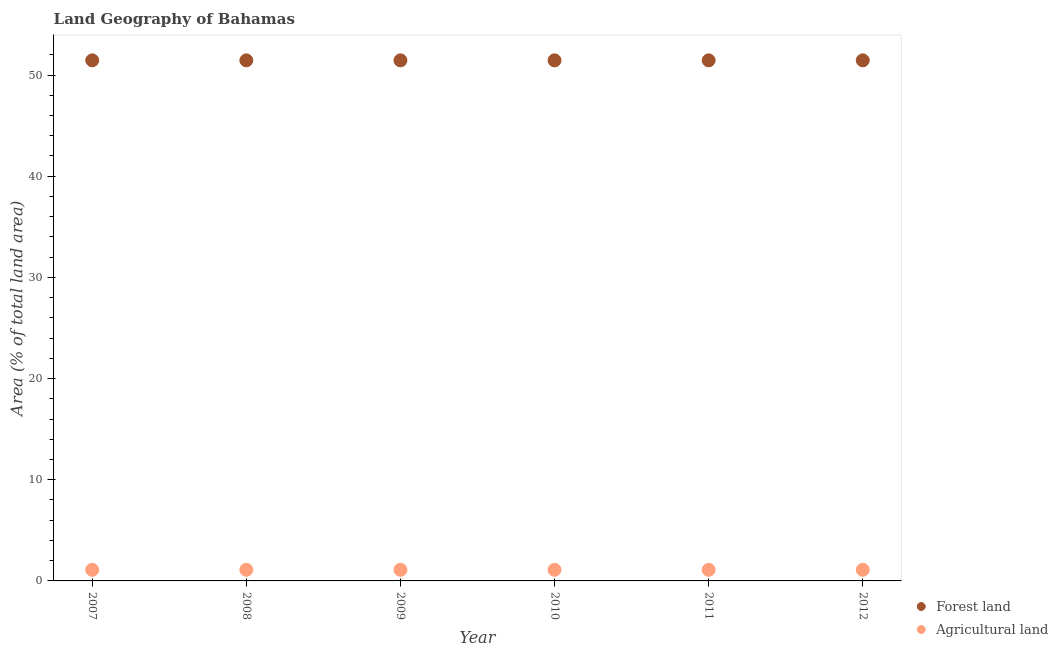What is the percentage of land area under agriculture in 2011?
Give a very brief answer. 1.1. Across all years, what is the maximum percentage of land area under agriculture?
Keep it short and to the point. 1.1. Across all years, what is the minimum percentage of land area under agriculture?
Ensure brevity in your answer.  1.1. In which year was the percentage of land area under agriculture maximum?
Offer a terse response. 2007. What is the total percentage of land area under agriculture in the graph?
Offer a terse response. 6.59. What is the difference between the percentage of land area under forests in 2007 and that in 2011?
Make the answer very short. 0. What is the difference between the percentage of land area under agriculture in 2007 and the percentage of land area under forests in 2012?
Provide a succinct answer. -50.35. What is the average percentage of land area under agriculture per year?
Offer a very short reply. 1.1. In the year 2008, what is the difference between the percentage of land area under agriculture and percentage of land area under forests?
Provide a short and direct response. -50.35. In how many years, is the percentage of land area under agriculture greater than 8 %?
Your response must be concise. 0. Is the difference between the percentage of land area under agriculture in 2009 and 2010 greater than the difference between the percentage of land area under forests in 2009 and 2010?
Give a very brief answer. No. What is the difference between the highest and the lowest percentage of land area under agriculture?
Your answer should be very brief. 0. Is the percentage of land area under agriculture strictly greater than the percentage of land area under forests over the years?
Keep it short and to the point. No. How many dotlines are there?
Ensure brevity in your answer.  2. What is the difference between two consecutive major ticks on the Y-axis?
Your answer should be compact. 10. Are the values on the major ticks of Y-axis written in scientific E-notation?
Your answer should be compact. No. Does the graph contain any zero values?
Provide a short and direct response. No. Does the graph contain grids?
Give a very brief answer. No. How are the legend labels stacked?
Keep it short and to the point. Vertical. What is the title of the graph?
Provide a succinct answer. Land Geography of Bahamas. What is the label or title of the Y-axis?
Ensure brevity in your answer.  Area (% of total land area). What is the Area (% of total land area) in Forest land in 2007?
Offer a terse response. 51.45. What is the Area (% of total land area) in Agricultural land in 2007?
Provide a short and direct response. 1.1. What is the Area (% of total land area) in Forest land in 2008?
Ensure brevity in your answer.  51.45. What is the Area (% of total land area) in Agricultural land in 2008?
Your answer should be compact. 1.1. What is the Area (% of total land area) in Forest land in 2009?
Keep it short and to the point. 51.45. What is the Area (% of total land area) in Agricultural land in 2009?
Make the answer very short. 1.1. What is the Area (% of total land area) in Forest land in 2010?
Your response must be concise. 51.45. What is the Area (% of total land area) of Agricultural land in 2010?
Your response must be concise. 1.1. What is the Area (% of total land area) in Forest land in 2011?
Keep it short and to the point. 51.45. What is the Area (% of total land area) of Agricultural land in 2011?
Offer a terse response. 1.1. What is the Area (% of total land area) of Forest land in 2012?
Give a very brief answer. 51.45. What is the Area (% of total land area) in Agricultural land in 2012?
Keep it short and to the point. 1.1. Across all years, what is the maximum Area (% of total land area) in Forest land?
Provide a short and direct response. 51.45. Across all years, what is the maximum Area (% of total land area) of Agricultural land?
Your answer should be very brief. 1.1. Across all years, what is the minimum Area (% of total land area) in Forest land?
Your answer should be very brief. 51.45. Across all years, what is the minimum Area (% of total land area) in Agricultural land?
Offer a terse response. 1.1. What is the total Area (% of total land area) in Forest land in the graph?
Make the answer very short. 308.69. What is the total Area (% of total land area) of Agricultural land in the graph?
Your answer should be compact. 6.59. What is the difference between the Area (% of total land area) of Forest land in 2007 and that in 2008?
Give a very brief answer. 0. What is the difference between the Area (% of total land area) of Forest land in 2007 and that in 2010?
Provide a succinct answer. 0. What is the difference between the Area (% of total land area) of Agricultural land in 2007 and that in 2010?
Ensure brevity in your answer.  0. What is the difference between the Area (% of total land area) in Agricultural land in 2007 and that in 2011?
Keep it short and to the point. 0. What is the difference between the Area (% of total land area) of Agricultural land in 2007 and that in 2012?
Offer a very short reply. 0. What is the difference between the Area (% of total land area) in Forest land in 2008 and that in 2009?
Ensure brevity in your answer.  0. What is the difference between the Area (% of total land area) in Forest land in 2008 and that in 2010?
Offer a very short reply. 0. What is the difference between the Area (% of total land area) in Agricultural land in 2008 and that in 2010?
Offer a very short reply. 0. What is the difference between the Area (% of total land area) of Agricultural land in 2008 and that in 2011?
Offer a very short reply. 0. What is the difference between the Area (% of total land area) in Forest land in 2008 and that in 2012?
Make the answer very short. 0. What is the difference between the Area (% of total land area) in Forest land in 2009 and that in 2010?
Provide a short and direct response. 0. What is the difference between the Area (% of total land area) in Agricultural land in 2009 and that in 2010?
Your response must be concise. 0. What is the difference between the Area (% of total land area) of Forest land in 2009 and that in 2012?
Offer a very short reply. 0. What is the difference between the Area (% of total land area) of Agricultural land in 2010 and that in 2011?
Provide a succinct answer. 0. What is the difference between the Area (% of total land area) of Agricultural land in 2010 and that in 2012?
Offer a very short reply. 0. What is the difference between the Area (% of total land area) in Forest land in 2011 and that in 2012?
Offer a very short reply. 0. What is the difference between the Area (% of total land area) in Forest land in 2007 and the Area (% of total land area) in Agricultural land in 2008?
Offer a terse response. 50.35. What is the difference between the Area (% of total land area) in Forest land in 2007 and the Area (% of total land area) in Agricultural land in 2009?
Keep it short and to the point. 50.35. What is the difference between the Area (% of total land area) in Forest land in 2007 and the Area (% of total land area) in Agricultural land in 2010?
Your answer should be compact. 50.35. What is the difference between the Area (% of total land area) in Forest land in 2007 and the Area (% of total land area) in Agricultural land in 2011?
Keep it short and to the point. 50.35. What is the difference between the Area (% of total land area) of Forest land in 2007 and the Area (% of total land area) of Agricultural land in 2012?
Your answer should be compact. 50.35. What is the difference between the Area (% of total land area) of Forest land in 2008 and the Area (% of total land area) of Agricultural land in 2009?
Offer a very short reply. 50.35. What is the difference between the Area (% of total land area) of Forest land in 2008 and the Area (% of total land area) of Agricultural land in 2010?
Keep it short and to the point. 50.35. What is the difference between the Area (% of total land area) in Forest land in 2008 and the Area (% of total land area) in Agricultural land in 2011?
Your answer should be compact. 50.35. What is the difference between the Area (% of total land area) in Forest land in 2008 and the Area (% of total land area) in Agricultural land in 2012?
Your answer should be compact. 50.35. What is the difference between the Area (% of total land area) in Forest land in 2009 and the Area (% of total land area) in Agricultural land in 2010?
Provide a succinct answer. 50.35. What is the difference between the Area (% of total land area) of Forest land in 2009 and the Area (% of total land area) of Agricultural land in 2011?
Offer a terse response. 50.35. What is the difference between the Area (% of total land area) in Forest land in 2009 and the Area (% of total land area) in Agricultural land in 2012?
Keep it short and to the point. 50.35. What is the difference between the Area (% of total land area) in Forest land in 2010 and the Area (% of total land area) in Agricultural land in 2011?
Give a very brief answer. 50.35. What is the difference between the Area (% of total land area) in Forest land in 2010 and the Area (% of total land area) in Agricultural land in 2012?
Provide a short and direct response. 50.35. What is the difference between the Area (% of total land area) in Forest land in 2011 and the Area (% of total land area) in Agricultural land in 2012?
Offer a very short reply. 50.35. What is the average Area (% of total land area) in Forest land per year?
Your answer should be compact. 51.45. What is the average Area (% of total land area) of Agricultural land per year?
Ensure brevity in your answer.  1.1. In the year 2007, what is the difference between the Area (% of total land area) of Forest land and Area (% of total land area) of Agricultural land?
Your answer should be very brief. 50.35. In the year 2008, what is the difference between the Area (% of total land area) of Forest land and Area (% of total land area) of Agricultural land?
Your answer should be very brief. 50.35. In the year 2009, what is the difference between the Area (% of total land area) of Forest land and Area (% of total land area) of Agricultural land?
Your response must be concise. 50.35. In the year 2010, what is the difference between the Area (% of total land area) in Forest land and Area (% of total land area) in Agricultural land?
Offer a terse response. 50.35. In the year 2011, what is the difference between the Area (% of total land area) of Forest land and Area (% of total land area) of Agricultural land?
Your answer should be very brief. 50.35. In the year 2012, what is the difference between the Area (% of total land area) in Forest land and Area (% of total land area) in Agricultural land?
Provide a succinct answer. 50.35. What is the ratio of the Area (% of total land area) in Forest land in 2007 to that in 2008?
Provide a short and direct response. 1. What is the ratio of the Area (% of total land area) of Forest land in 2007 to that in 2010?
Offer a terse response. 1. What is the ratio of the Area (% of total land area) in Agricultural land in 2007 to that in 2010?
Offer a terse response. 1. What is the ratio of the Area (% of total land area) of Forest land in 2008 to that in 2010?
Make the answer very short. 1. What is the ratio of the Area (% of total land area) of Agricultural land in 2008 to that in 2010?
Ensure brevity in your answer.  1. What is the ratio of the Area (% of total land area) of Agricultural land in 2008 to that in 2012?
Keep it short and to the point. 1. What is the ratio of the Area (% of total land area) in Forest land in 2009 to that in 2010?
Keep it short and to the point. 1. What is the ratio of the Area (% of total land area) in Forest land in 2009 to that in 2011?
Your response must be concise. 1. What is the ratio of the Area (% of total land area) of Agricultural land in 2009 to that in 2011?
Ensure brevity in your answer.  1. What is the ratio of the Area (% of total land area) of Agricultural land in 2009 to that in 2012?
Give a very brief answer. 1. What is the ratio of the Area (% of total land area) in Agricultural land in 2010 to that in 2011?
Offer a very short reply. 1. What is the ratio of the Area (% of total land area) of Forest land in 2010 to that in 2012?
Your response must be concise. 1. What is the ratio of the Area (% of total land area) of Agricultural land in 2010 to that in 2012?
Your response must be concise. 1. What is the difference between the highest and the second highest Area (% of total land area) of Forest land?
Offer a terse response. 0. What is the difference between the highest and the lowest Area (% of total land area) of Forest land?
Your response must be concise. 0. What is the difference between the highest and the lowest Area (% of total land area) of Agricultural land?
Your answer should be very brief. 0. 